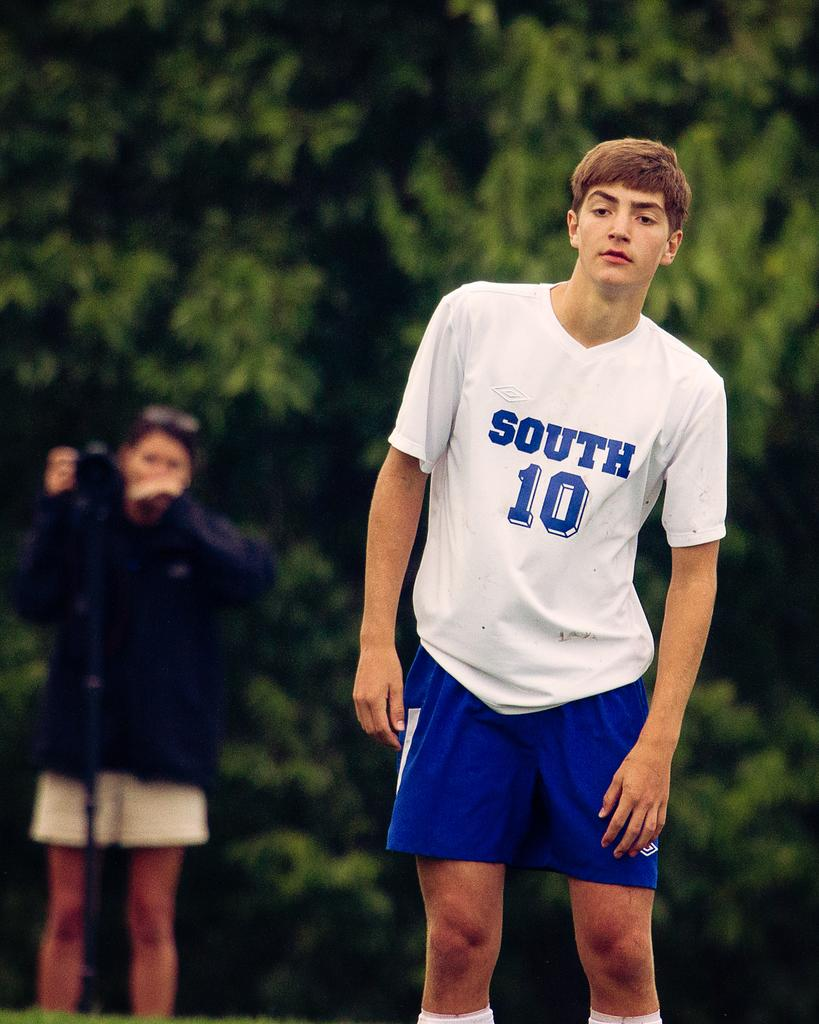Provide a one-sentence caption for the provided image. A soccer player wearing a blue and white jersey that says South 10 on it. 